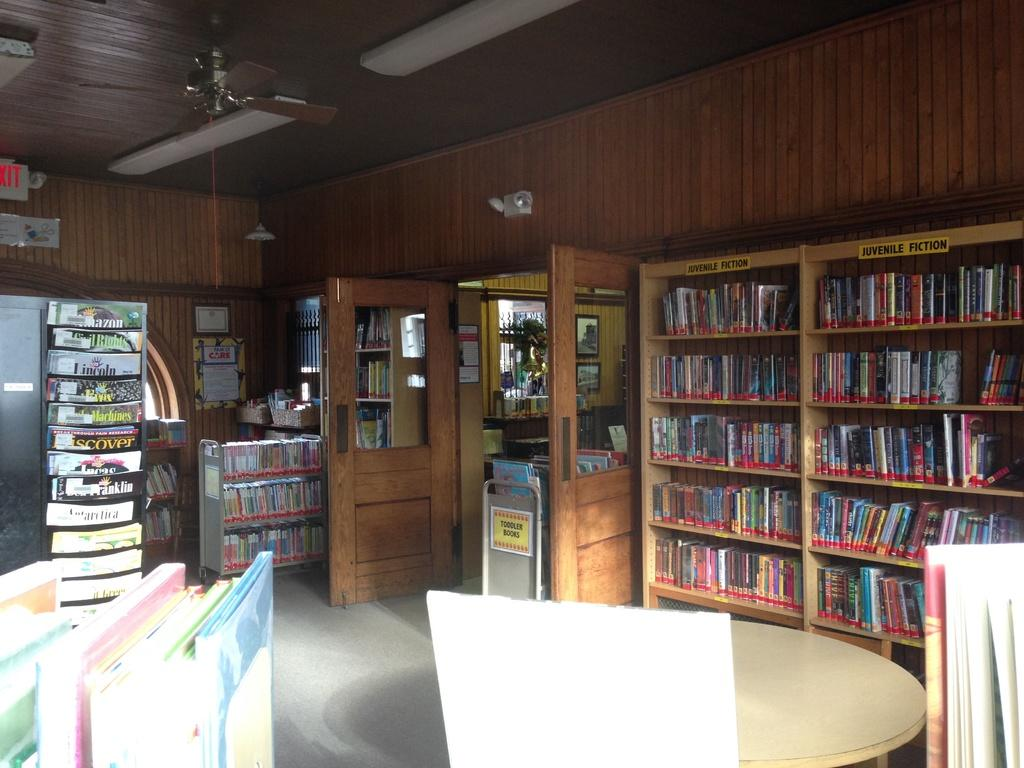What type of surface is visible at the bottom of the image? There is a floor in the image. What piece of furniture can be seen in the image? There is a table in the image. What type of items are present on the table? There are books in the image. What architectural features are visible in the image? There are doors and walls in the image. Where are the books located besides the table? There are books on shelves in the image. What device can be seen in the image? There is a fan in the image. What is the upper boundary of the room in the image? There is a ceiling in the image. Can you describe any other objects present in the image? There are some objects in the image. What type of wave can be seen crashing against the shore in the image? There is no wave or shore present in the image; it is an indoor room with various objects and furniture. 